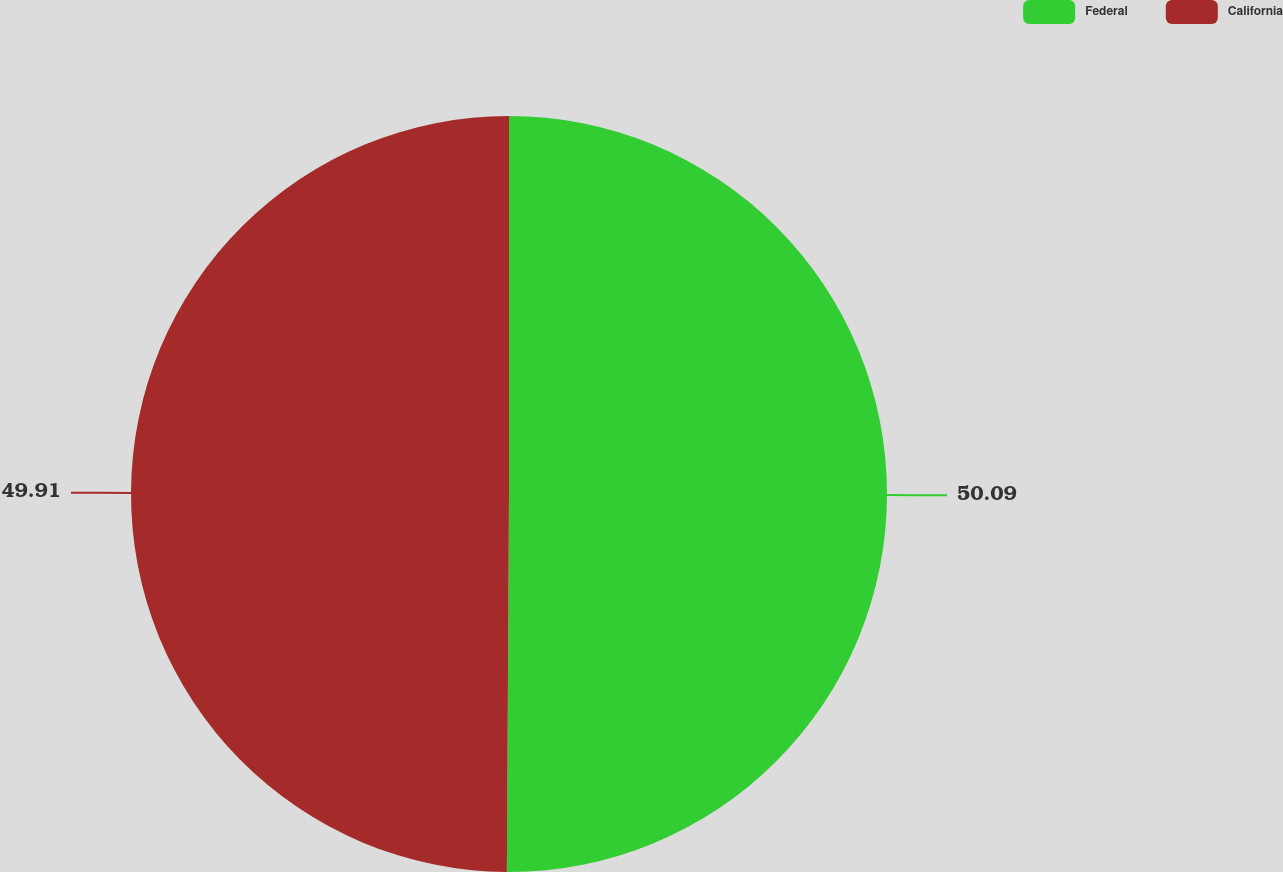<chart> <loc_0><loc_0><loc_500><loc_500><pie_chart><fcel>Federal<fcel>California<nl><fcel>50.09%<fcel>49.91%<nl></chart> 